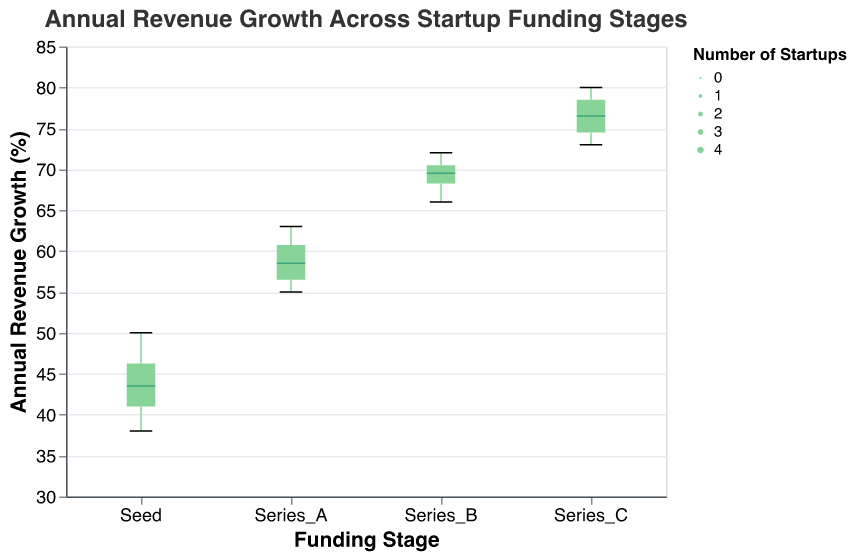What's the title of the figure? The title is located at the top of the figure and it specifies the main topic of the plot.
Answer: Annual Revenue Growth Across Startup Funding Stages What is the range of the y-axis? The y-axis represents the Annual Revenue Growth Percentage and its scale is shown on the left side of the plot, ranging from 30 to 85.
Answer: 30 to 85 Which funding stage has the highest median revenue growth? The median is represented by the line inside the box of the boxplot. By looking at the positions of these lines, the highest one is for the Series C funding stage.
Answer: Series C How many startups are at the Seed funding stage? The size of the boxplot depends on the number of observations. Each boxplot's width is proportional to the number of startups. For the Seed stage, there are four startups indicated by its width.
Answer: 4 What's the min and max annual revenue growth percentage for Series A startups? The minimum and maximum values are indicated by the whiskers of the boxplot. For Series A, the whiskers extend from 55% to 63%.
Answer: Min: 55%, Max: 63% Which funding stage has the narrowest range of annual revenue growth? The range of each funding stage is determined by the distance between the minimum and maximum points in the whiskers. Series A has the narrowest range since the whiskers are closest together.
Answer: Series A What is the median annual revenue growth percentage for startups in the Series B stage? The median is shown as a line within the box of the boxplot. In the Series B stage, this line is at 70%.
Answer: 70% Which funding stage has the widest distribution of annual revenue growth? The widest distribution is determined by the length between the whiskers. Series C shows the largest range from around 73% to 80%.
Answer: Series C Between Seed and Series A stages, which one shows higher variability in revenue growth percentages? Variability is indicated by the range between the whiskers. The Seed stage has a wider range (38% to 50%) compared to Series A (55% to 63%).
Answer: Seed 